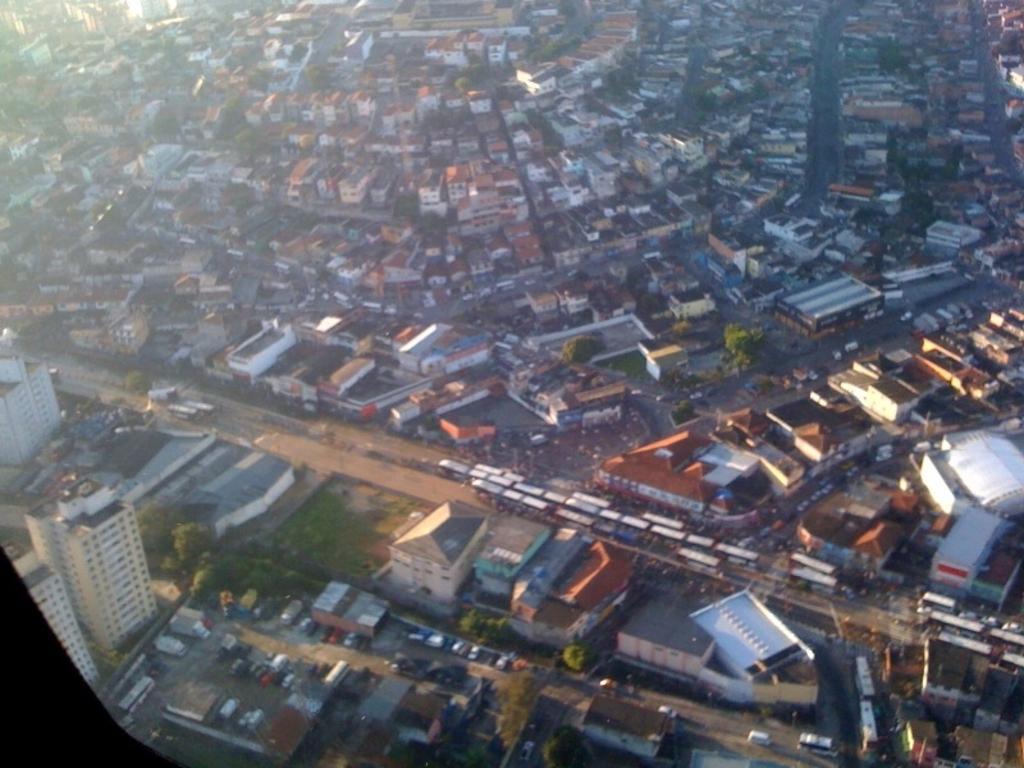In one or two sentences, can you explain what this image depicts? In the image we can see some buildings and trees and vehicles. 